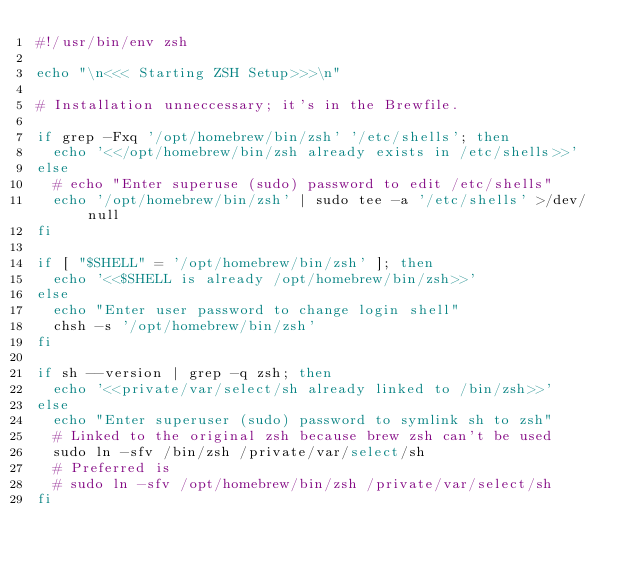<code> <loc_0><loc_0><loc_500><loc_500><_Bash_>#!/usr/bin/env zsh

echo "\n<<< Starting ZSH Setup>>>\n"

# Installation unneccessary; it's in the Brewfile.

if grep -Fxq '/opt/homebrew/bin/zsh' '/etc/shells'; then
  echo '<</opt/homebrew/bin/zsh already exists in /etc/shells>>'
else
  # echo "Enter superuse (sudo) password to edit /etc/shells"
  echo '/opt/homebrew/bin/zsh' | sudo tee -a '/etc/shells' >/dev/null
fi

if [ "$SHELL" = '/opt/homebrew/bin/zsh' ]; then
  echo '<<$SHELL is already /opt/homebrew/bin/zsh>>'
else
  echo "Enter user password to change login shell"
  chsh -s '/opt/homebrew/bin/zsh'
fi

if sh --version | grep -q zsh; then
  echo '<<private/var/select/sh already linked to /bin/zsh>>'
else
  echo "Enter superuser (sudo) password to symlink sh to zsh"
  # Linked to the original zsh because brew zsh can't be used
  sudo ln -sfv /bin/zsh /private/var/select/sh 
  # Preferred is
  # sudo ln -sfv /opt/homebrew/bin/zsh /private/var/select/sh
fi
</code> 